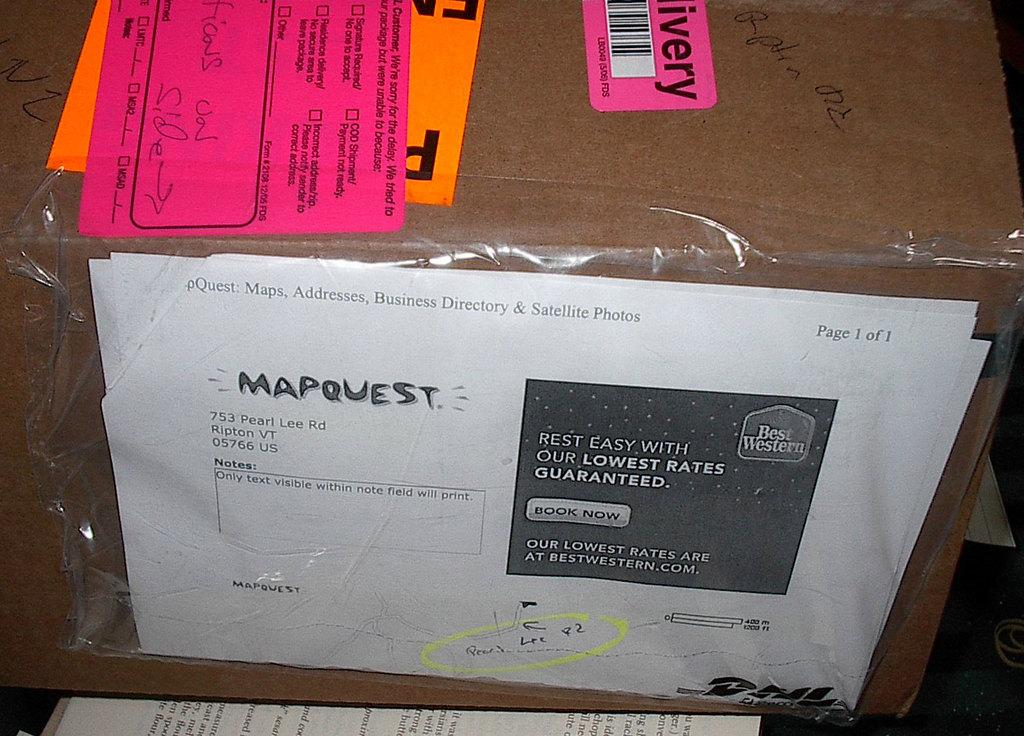<image>
Give a short and clear explanation of the subsequent image. A box package has a MapQuest label on the side of it. 